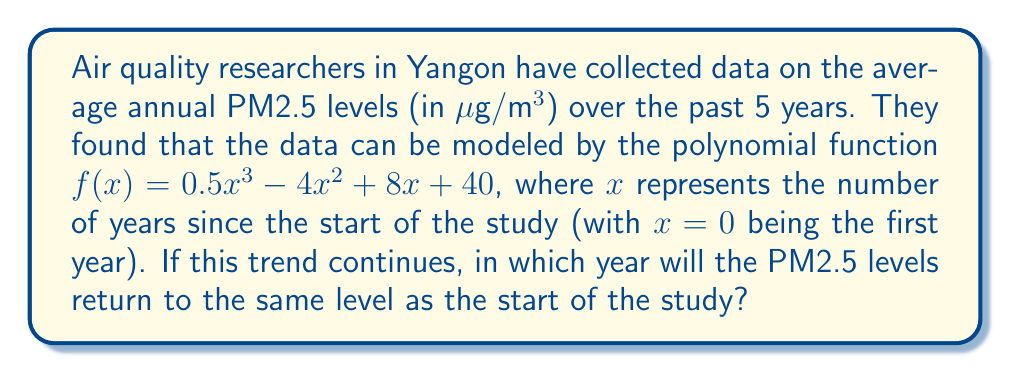Show me your answer to this math problem. To solve this problem, we need to follow these steps:

1) The PM2.5 level at the start of the study (when $x = 0$) is:
   $f(0) = 0.5(0)^3 - 4(0)^2 + 8(0) + 40 = 40$ μg/m³

2) We need to find when the function will again equal 40. This means solving the equation:
   $0.5x^3 - 4x^2 + 8x + 40 = 40$

3) Simplify the equation:
   $0.5x^3 - 4x^2 + 8x = 0$

4) Factor out the common factor $x$:
   $x(0.5x^2 - 4x + 8) = 0$

5) Use the zero product property. Either $x = 0$ (which we know is not the solution we're looking for as it's the start year) or:
   $0.5x^2 - 4x + 8 = 0$

6) Solve this quadratic equation using the quadratic formula:
   $x = \frac{-b \pm \sqrt{b^2 - 4ac}}{2a}$
   where $a = 0.5$, $b = -4$, and $c = 8$

7) Plugging in these values:
   $x = \frac{4 \pm \sqrt{16 - 16}}{1} = \frac{4 \pm 0}{1} = 4$

8) Therefore, the PM2.5 levels will return to the initial level after 4 years.

9) Since the study started 5 years ago, the levels will return to the initial value 4 years from now, which is 9 years from the start of the study.
Answer: The PM2.5 levels will return to the same level as the start of the study 9 years after the beginning of the study. 